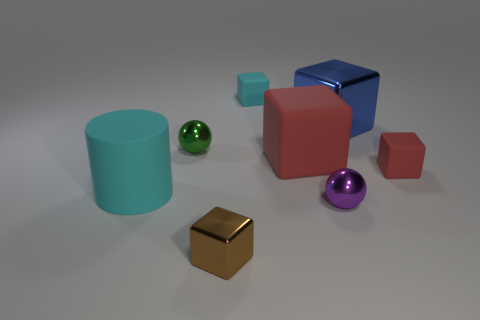Are there the same number of large red matte cubes that are left of the cyan cylinder and purple rubber cubes?
Your answer should be very brief. Yes. Do the small red matte thing and the small cyan object have the same shape?
Ensure brevity in your answer.  Yes. Is there anything else of the same color as the small metal cube?
Offer a very short reply. No. There is a object that is both on the left side of the small brown thing and to the right of the cyan matte cylinder; what is its shape?
Give a very brief answer. Sphere. Are there the same number of tiny rubber cubes behind the tiny cyan thing and small cubes that are left of the tiny red object?
Keep it short and to the point. No. What number of cylinders are either things or small cyan things?
Your answer should be compact. 1. What number of other red objects are made of the same material as the tiny red object?
Keep it short and to the point. 1. There is a small rubber thing that is the same color as the cylinder; what is its shape?
Offer a terse response. Cube. What is the large thing that is both to the right of the tiny green ball and in front of the tiny green shiny thing made of?
Your answer should be compact. Rubber. What shape is the large matte object on the right side of the green sphere?
Your answer should be very brief. Cube. 